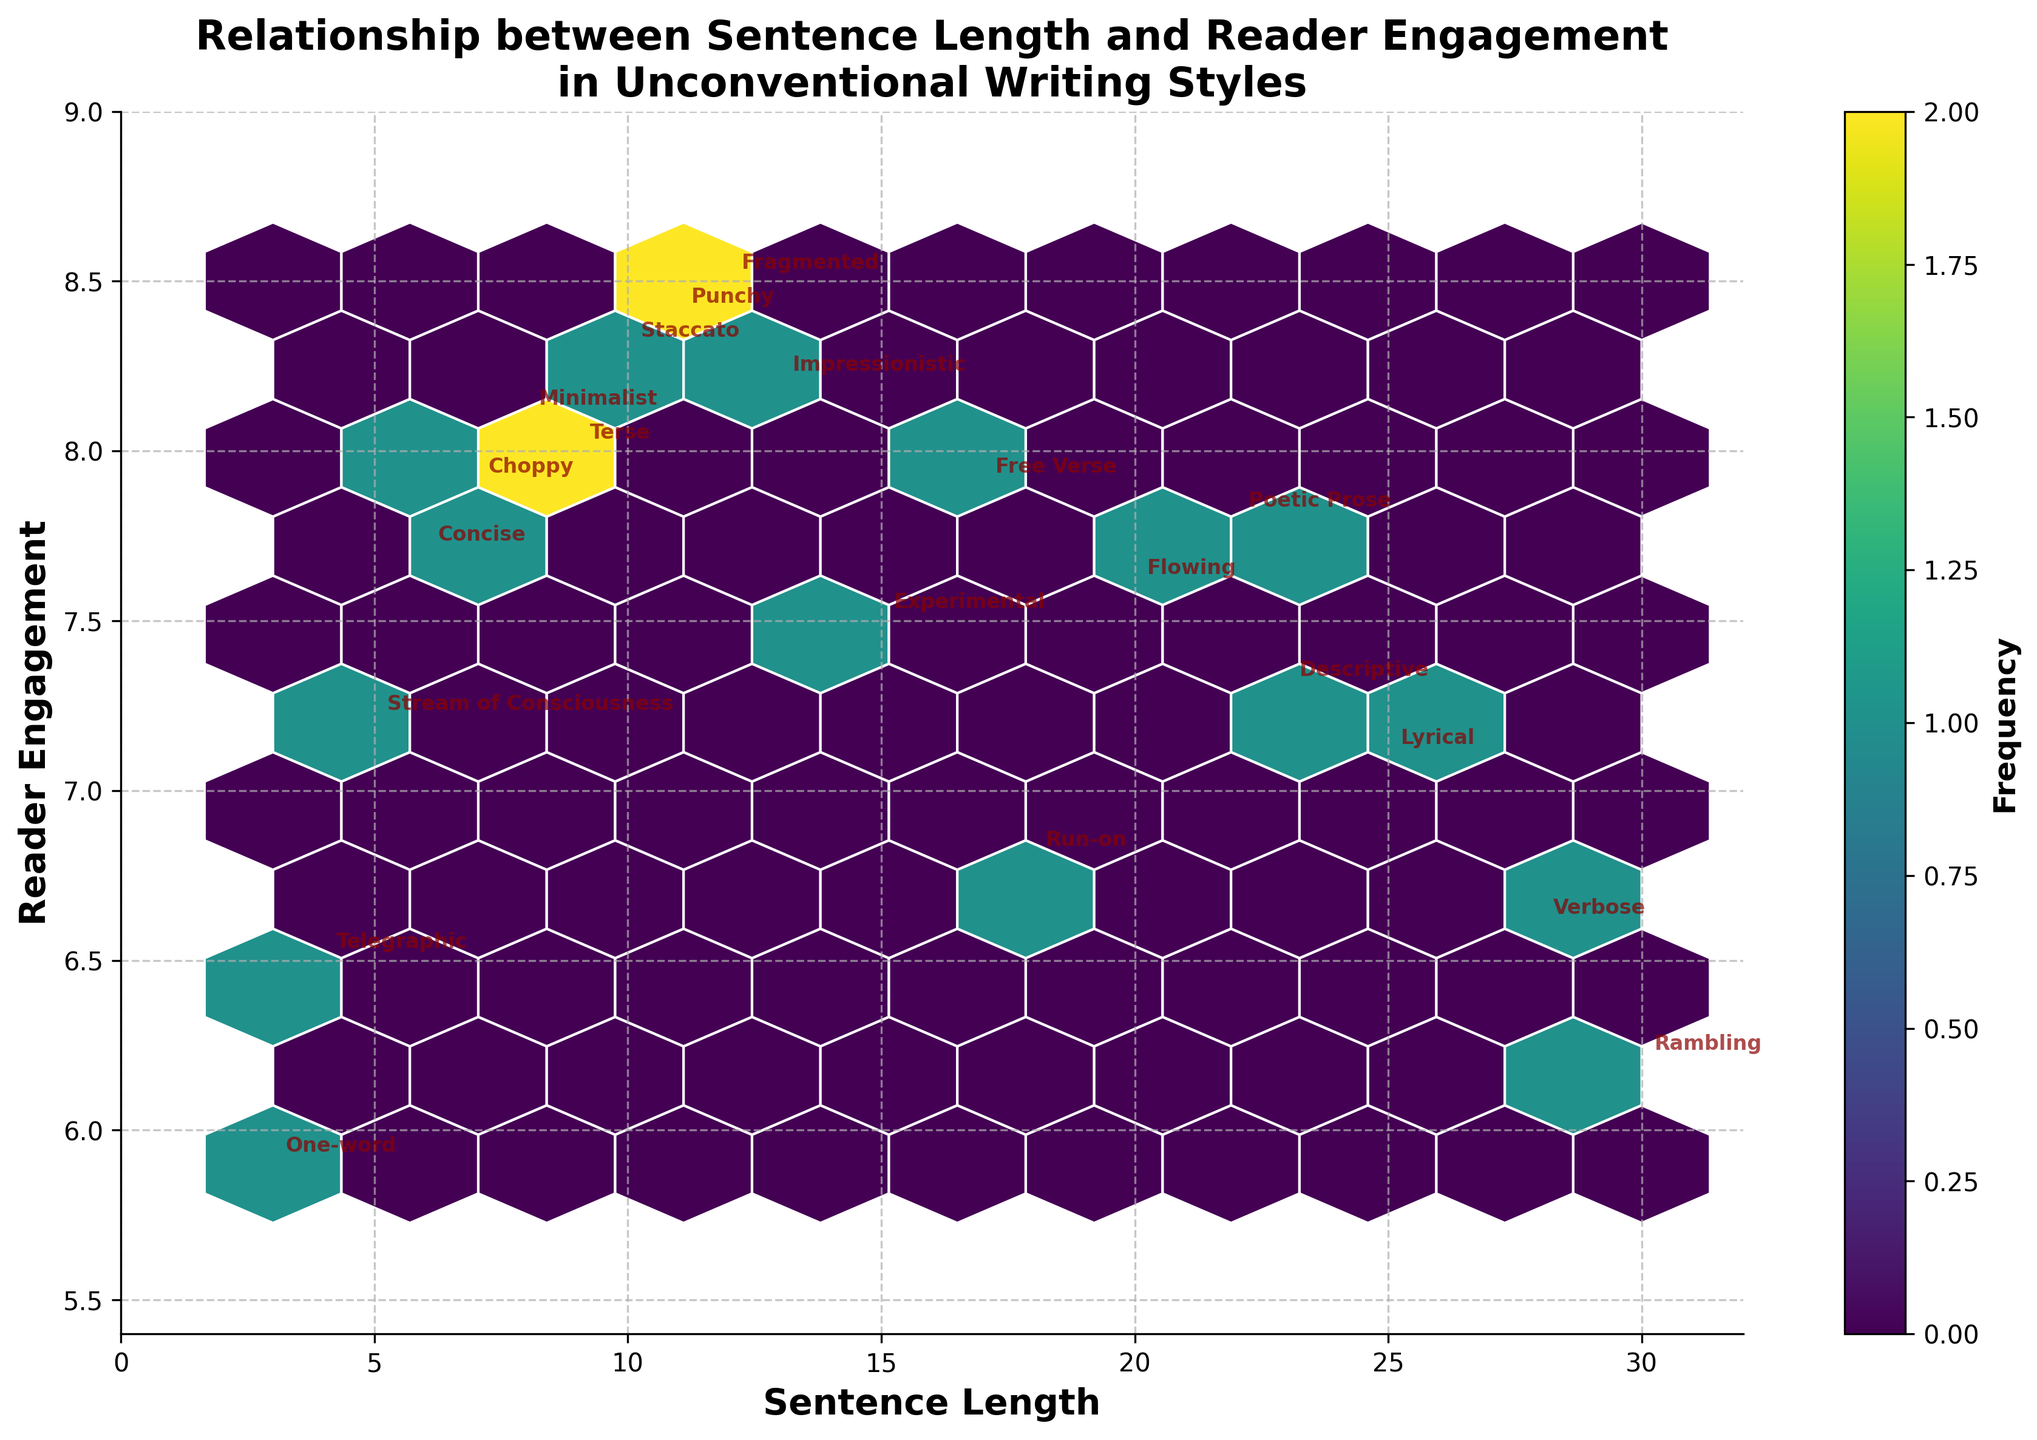What is the title of the figure? The title is typically located at the top of the figure. The title describes the main theme or subject being visualized.
Answer: Relationship between Sentence Length and Reader Engagement in Unconventional Writing Styles How many data points are plotted in the hexbin plot? Count the annotations present around each hexbin to verify the total number of data points. Each annotated style represents one data point.
Answer: 20 What is the sentence length for the writing style "Punchy"? Locate the "Punchy" text annotation on the plot and read the corresponding x-axis value beneath this annotation.
Answer: 11 Which writing style shows the highest reader engagement? Find the data point/annotation with the highest position on the y-axis; this corresponds to the writing style with the maximum reader engagement value.
Answer: Fragmented Is there a positive or negative general trend between sentence length and reader engagement? Observe whether data points generally trend upward (positive correlation) or downward (negative correlation) as sentence length increases along the x-axis.
Answer: Generally negative What is the reader engagement for the writing style "Verbose"? Locate the "Verbose" text annotation and check the corresponding y-axis value to determine the reader engagement level.
Answer: 6.6 Which writing style has the shortest sentence length, and what is its reader engagement? Identify the annotation closest to the y-axis intercept; this corresponds with the shortest sentence length. Read the reader engagement value as well.
Answer: One-word, 5.9 Compare the reader engagement between "Run-on" and "Lyrical" writing styles. Which one has a higher engagement? Find the y-axis values corresponding to the annotations for "Run-on" and "Lyrical" and compare which one is higher.
Answer: Lyrical What can be said about the data density around sentence lengths of 10-15? Observe the hexbin density (color intensity) in the area around sentence lengths of 10-15 and infer whether it's high or low based on color density.
Answer: High density Is there a writing style with a sentence length greater than 25 but with lower reader engagement compared to "Experimental"? Locate the data points where sentence length exceeds 25, then check if their reader engagement values are below that of the "Experimental" style's engagement.
Answer: Yes, Verbose 